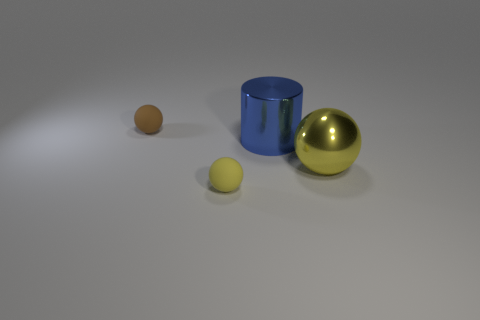How many yellow balls must be subtracted to get 1 yellow balls? 1 Subtract all small spheres. How many spheres are left? 1 Add 2 large cyan shiny spheres. How many objects exist? 6 Subtract all cylinders. How many objects are left? 3 Add 3 gray cylinders. How many gray cylinders exist? 3 Subtract 0 purple cylinders. How many objects are left? 4 Subtract all yellow rubber cubes. Subtract all large metal balls. How many objects are left? 3 Add 4 small brown matte balls. How many small brown matte balls are left? 5 